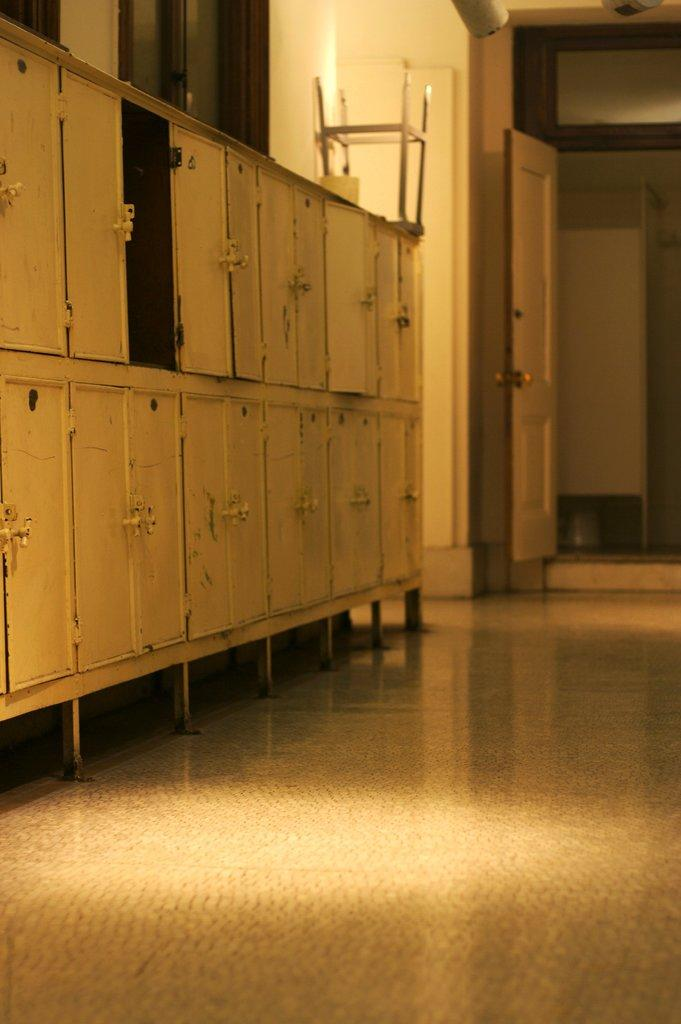What type of storage units are present in the image? There are lockers in the image. What can be seen in the background of the image? There are doors in the background of the image. What surface is visible at the bottom of the image? There is a floor visible at the bottom of the image. What type of wealth is being displayed in the image? There is no indication of wealth being displayed in the image; it features lockers and doors. What type of feast is being prepared in the image? There is no feast or food preparation visible in the image; it only shows lockers, doors, and a floor. 